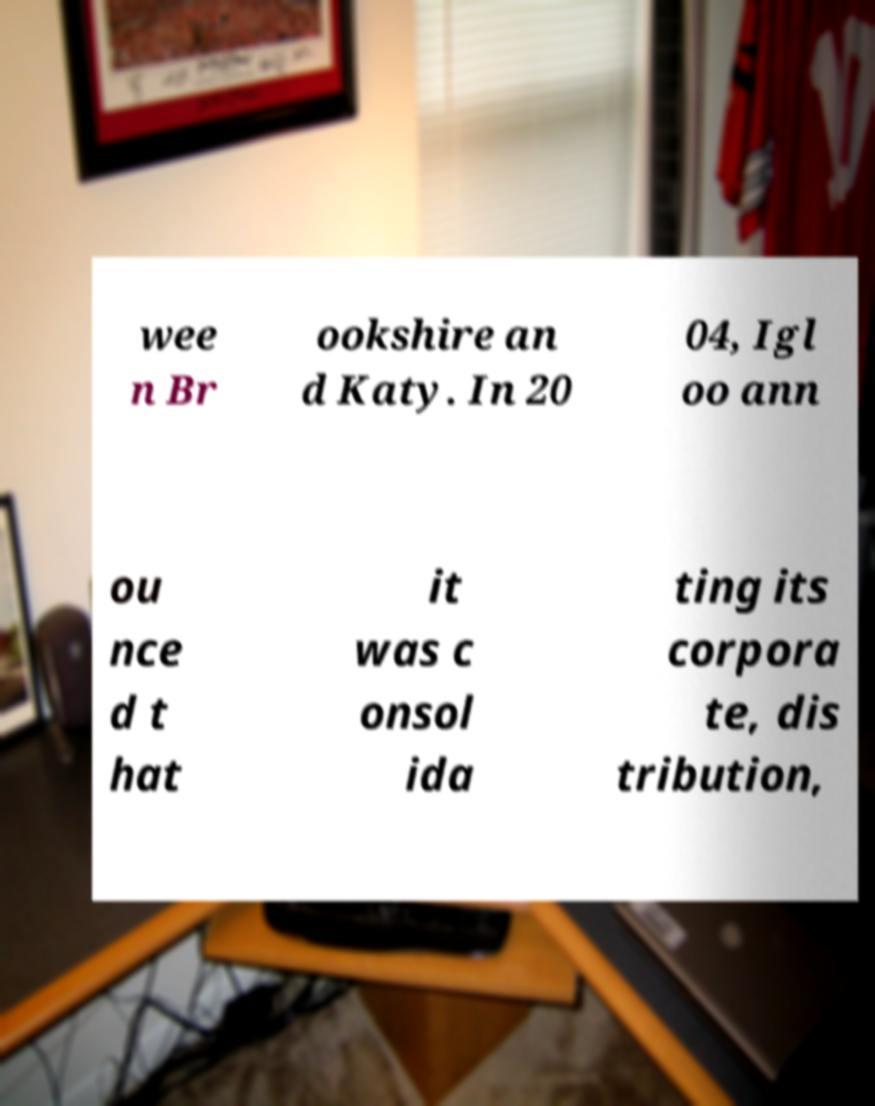Please identify and transcribe the text found in this image. wee n Br ookshire an d Katy. In 20 04, Igl oo ann ou nce d t hat it was c onsol ida ting its corpora te, dis tribution, 